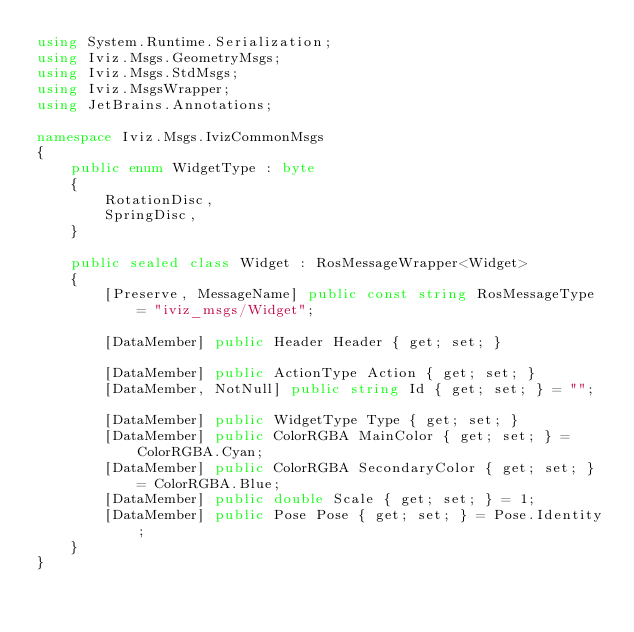Convert code to text. <code><loc_0><loc_0><loc_500><loc_500><_C#_>using System.Runtime.Serialization;
using Iviz.Msgs.GeometryMsgs;
using Iviz.Msgs.StdMsgs;
using Iviz.MsgsWrapper;
using JetBrains.Annotations;

namespace Iviz.Msgs.IvizCommonMsgs
{
    public enum WidgetType : byte
    {
        RotationDisc,
        SpringDisc,
    }
    
    public sealed class Widget : RosMessageWrapper<Widget>
    {
        [Preserve, MessageName] public const string RosMessageType = "iviz_msgs/Widget";
        
        [DataMember] public Header Header { get; set; }

        [DataMember] public ActionType Action { get; set; }
        [DataMember, NotNull] public string Id { get; set; } = "";

        [DataMember] public WidgetType Type { get; set; }
        [DataMember] public ColorRGBA MainColor { get; set; } = ColorRGBA.Cyan;
        [DataMember] public ColorRGBA SecondaryColor { get; set; } = ColorRGBA.Blue;
        [DataMember] public double Scale { get; set; } = 1;
        [DataMember] public Pose Pose { get; set; } = Pose.Identity;
    }
}</code> 